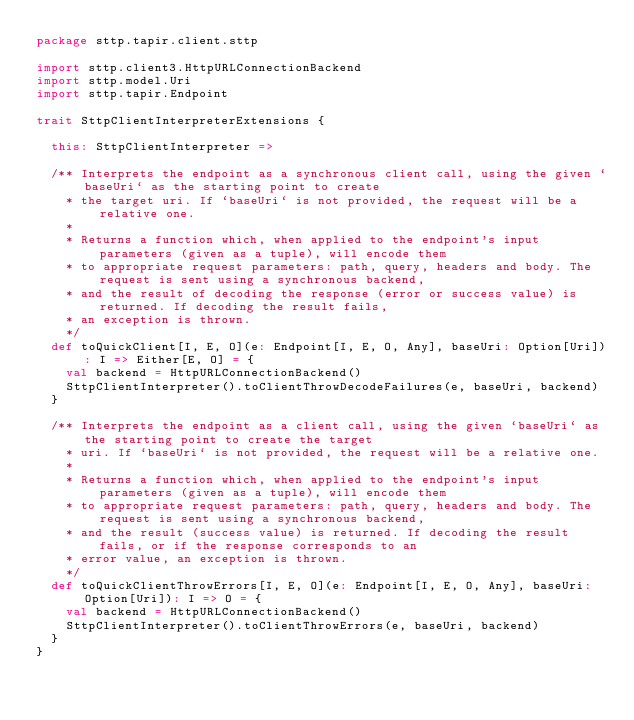<code> <loc_0><loc_0><loc_500><loc_500><_Scala_>package sttp.tapir.client.sttp

import sttp.client3.HttpURLConnectionBackend
import sttp.model.Uri
import sttp.tapir.Endpoint

trait SttpClientInterpreterExtensions {

  this: SttpClientInterpreter =>

  /** Interprets the endpoint as a synchronous client call, using the given `baseUri` as the starting point to create
    * the target uri. If `baseUri` is not provided, the request will be a relative one.
    *
    * Returns a function which, when applied to the endpoint's input parameters (given as a tuple), will encode them
    * to appropriate request parameters: path, query, headers and body. The request is sent using a synchronous backend,
    * and the result of decoding the response (error or success value) is returned. If decoding the result fails,
    * an exception is thrown.
    */
  def toQuickClient[I, E, O](e: Endpoint[I, E, O, Any], baseUri: Option[Uri]): I => Either[E, O] = {
    val backend = HttpURLConnectionBackend()
    SttpClientInterpreter().toClientThrowDecodeFailures(e, baseUri, backend)
  }

  /** Interprets the endpoint as a client call, using the given `baseUri` as the starting point to create the target
    * uri. If `baseUri` is not provided, the request will be a relative one.
    *
    * Returns a function which, when applied to the endpoint's input parameters (given as a tuple), will encode them
    * to appropriate request parameters: path, query, headers and body. The request is sent using a synchronous backend,
    * and the result (success value) is returned. If decoding the result fails, or if the response corresponds to an
    * error value, an exception is thrown.
    */
  def toQuickClientThrowErrors[I, E, O](e: Endpoint[I, E, O, Any], baseUri: Option[Uri]): I => O = {
    val backend = HttpURLConnectionBackend()
    SttpClientInterpreter().toClientThrowErrors(e, baseUri, backend)
  }
}
</code> 